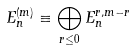Convert formula to latex. <formula><loc_0><loc_0><loc_500><loc_500>E _ { n } ^ { ( m ) } \equiv \bigoplus _ { r \leq 0 } E _ { n } ^ { r , m - r }</formula> 